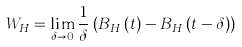<formula> <loc_0><loc_0><loc_500><loc_500>W _ { H } = \lim _ { \delta \rightarrow 0 } \frac { 1 } { \delta } \left ( B _ { H } \left ( t \right ) - B _ { H } \left ( t - \delta \right ) \right )</formula> 